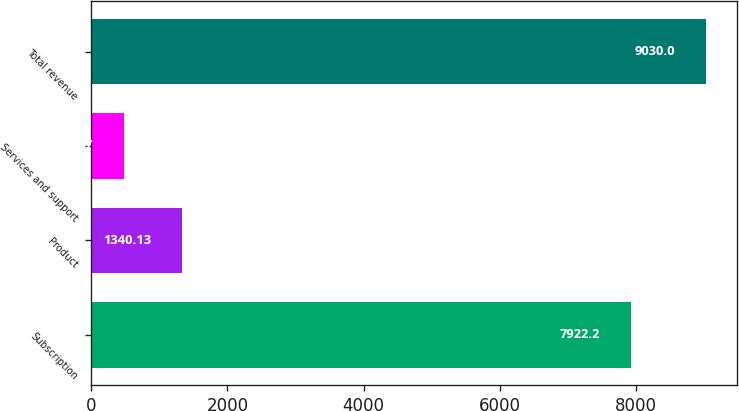<chart> <loc_0><loc_0><loc_500><loc_500><bar_chart><fcel>Subscription<fcel>Product<fcel>Services and support<fcel>Total revenue<nl><fcel>7922.2<fcel>1340.13<fcel>485.7<fcel>9030<nl></chart> 